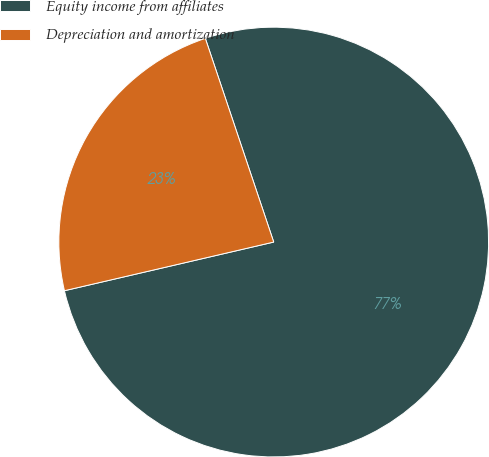<chart> <loc_0><loc_0><loc_500><loc_500><pie_chart><fcel>Equity income from affiliates<fcel>Depreciation and amortization<nl><fcel>76.52%<fcel>23.48%<nl></chart> 